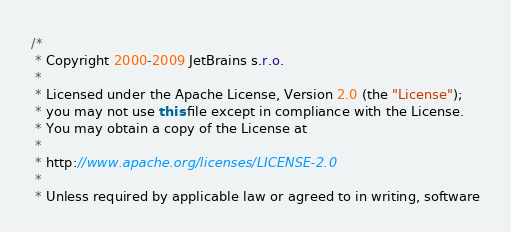Convert code to text. <code><loc_0><loc_0><loc_500><loc_500><_Java_>/*
 * Copyright 2000-2009 JetBrains s.r.o.
 *
 * Licensed under the Apache License, Version 2.0 (the "License");
 * you may not use this file except in compliance with the License.
 * You may obtain a copy of the License at
 *
 * http://www.apache.org/licenses/LICENSE-2.0
 *
 * Unless required by applicable law or agreed to in writing, software</code> 